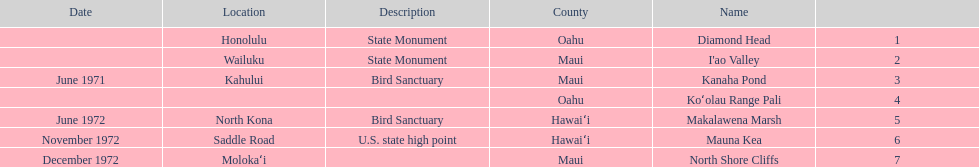Other than mauna kea, name a place in hawaii. Makalawena Marsh. 